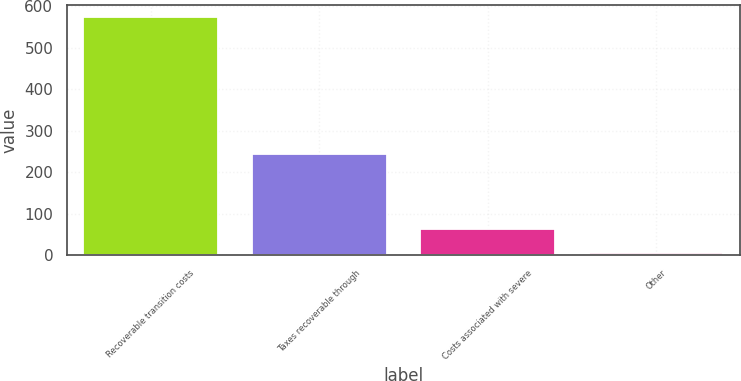Convert chart. <chart><loc_0><loc_0><loc_500><loc_500><bar_chart><fcel>Recoverable transition costs<fcel>Taxes recoverable through<fcel>Costs associated with severe<fcel>Other<nl><fcel>574<fcel>245<fcel>62.8<fcel>6<nl></chart> 